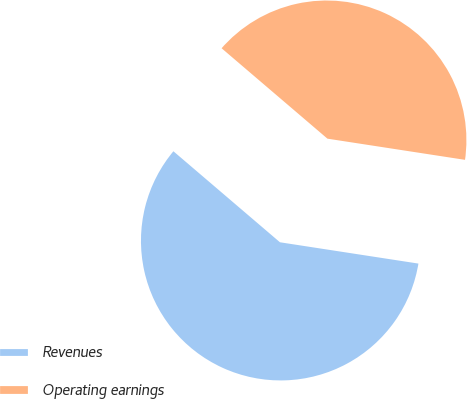Convert chart. <chart><loc_0><loc_0><loc_500><loc_500><pie_chart><fcel>Revenues<fcel>Operating earnings<nl><fcel>58.82%<fcel>41.18%<nl></chart> 